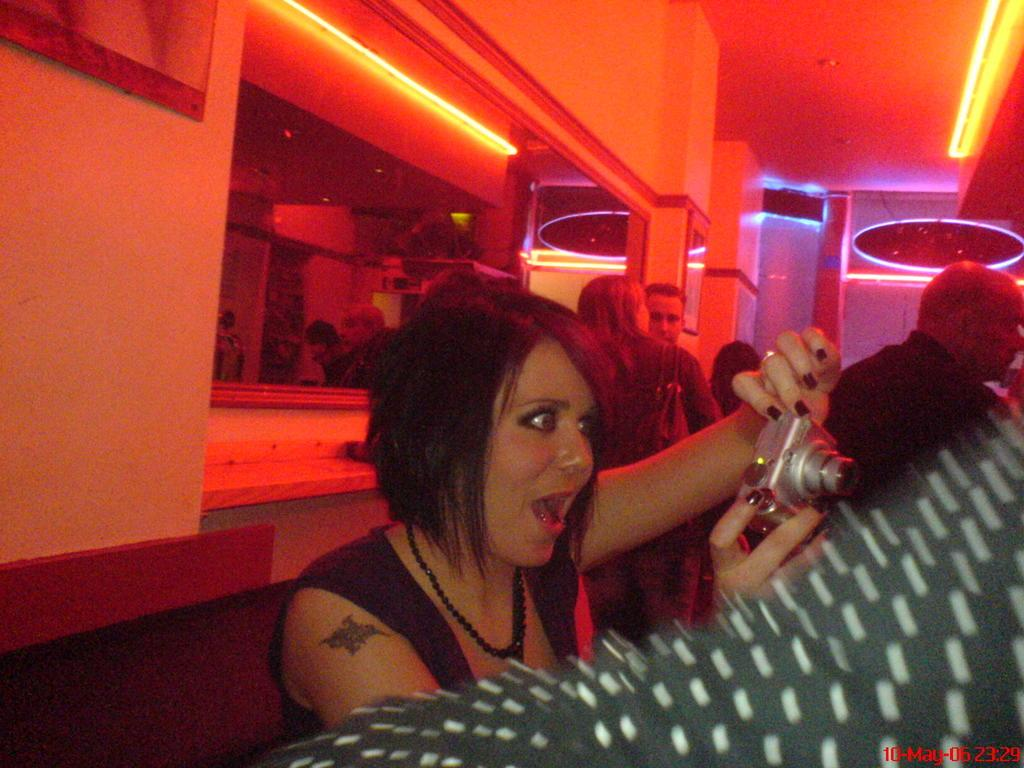How many people are in the image? There is a group of people in the image. What is the woman in the image holding? The woman is holding a camera in the image. What object in the image can be used for reflection? There is a mirror in the image. What is on the wall in the image? There is a board on a wall in the image. What type of lighting is present in the image? There are ceiling lights in the image. What type of voice can be heard in the image? There is no voice present in the image; it is a still image. What order are the people standing in the image? The image does not depict a specific order in which the people are standing. 